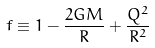<formula> <loc_0><loc_0><loc_500><loc_500>f \equiv 1 - \frac { 2 G M } { R } + \frac { Q ^ { 2 } } { R ^ { 2 } }</formula> 